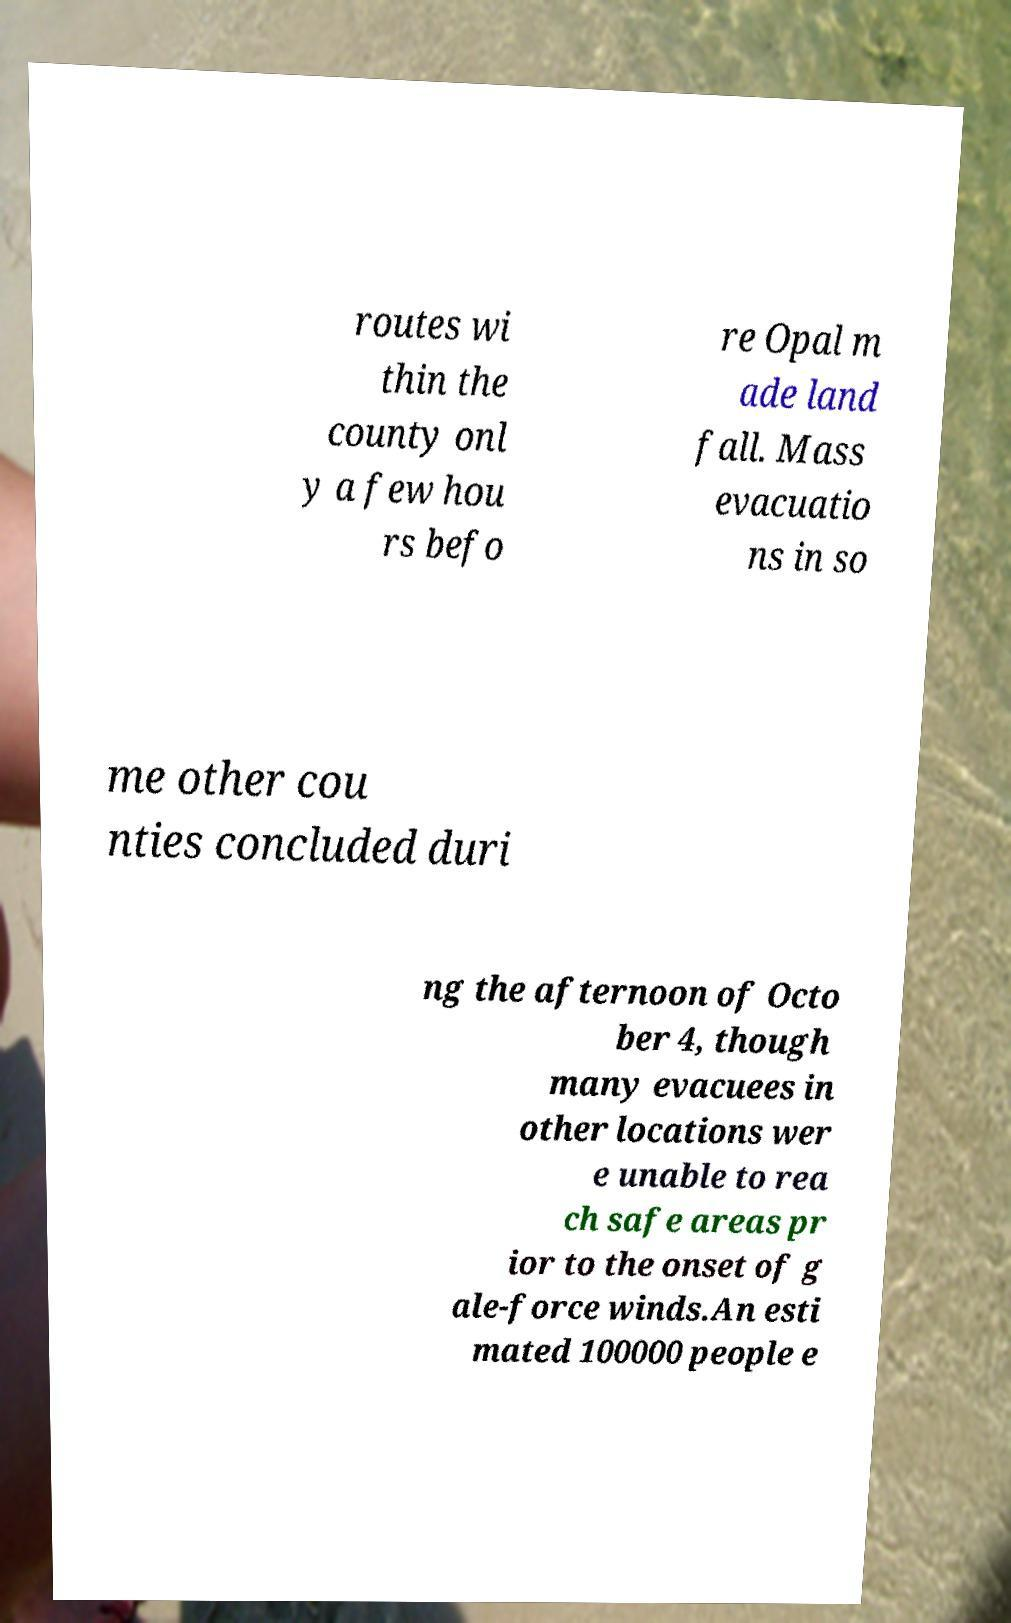Please read and relay the text visible in this image. What does it say? routes wi thin the county onl y a few hou rs befo re Opal m ade land fall. Mass evacuatio ns in so me other cou nties concluded duri ng the afternoon of Octo ber 4, though many evacuees in other locations wer e unable to rea ch safe areas pr ior to the onset of g ale-force winds.An esti mated 100000 people e 